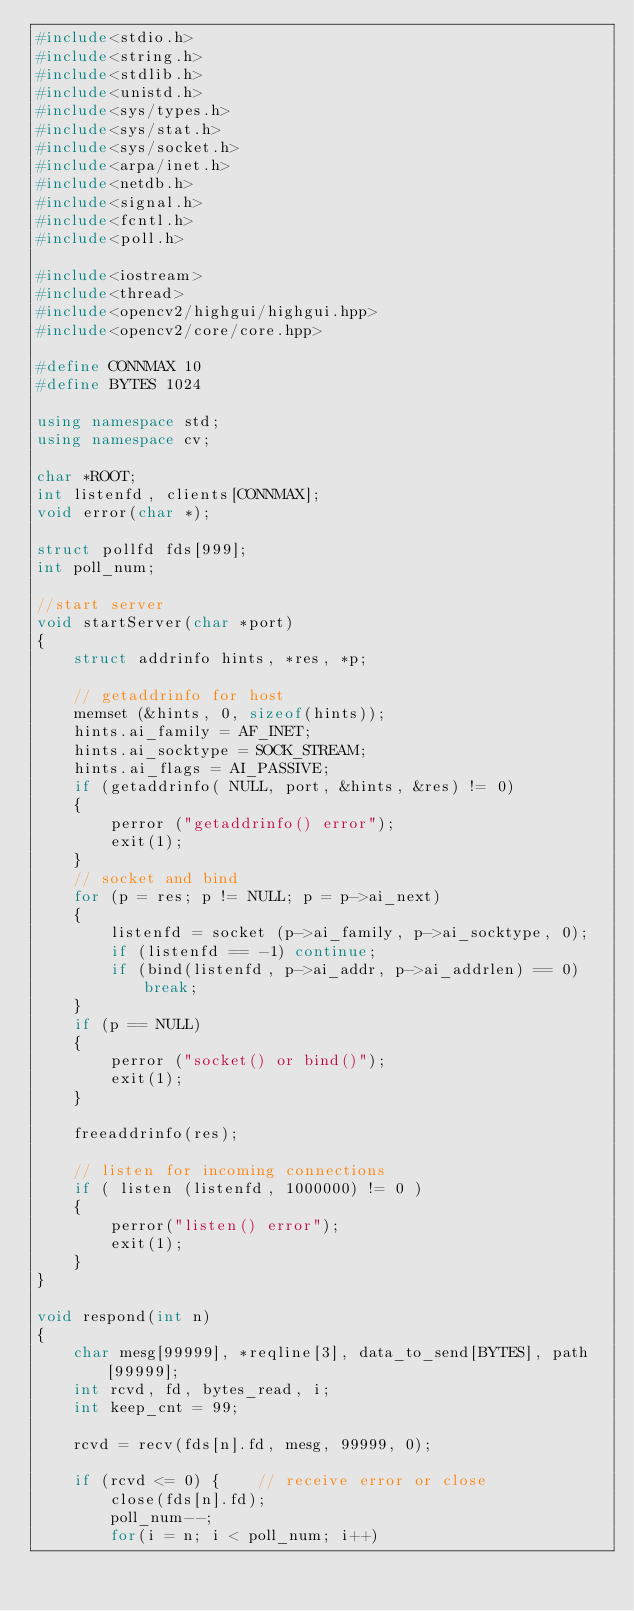<code> <loc_0><loc_0><loc_500><loc_500><_C++_>#include<stdio.h>
#include<string.h>
#include<stdlib.h>
#include<unistd.h>
#include<sys/types.h>
#include<sys/stat.h>
#include<sys/socket.h>
#include<arpa/inet.h>
#include<netdb.h>
#include<signal.h>
#include<fcntl.h>
#include<poll.h>

#include<iostream>
#include<thread>
#include<opencv2/highgui/highgui.hpp>
#include<opencv2/core/core.hpp>

#define CONNMAX 10
#define BYTES 1024

using namespace std;
using namespace cv;

char *ROOT;
int listenfd, clients[CONNMAX];
void error(char *);

struct pollfd fds[999];
int poll_num;

//start server
void startServer(char *port)
{
    struct addrinfo hints, *res, *p;

    // getaddrinfo for host
    memset (&hints, 0, sizeof(hints));
    hints.ai_family = AF_INET;
    hints.ai_socktype = SOCK_STREAM;
    hints.ai_flags = AI_PASSIVE;
    if (getaddrinfo( NULL, port, &hints, &res) != 0)
    {
        perror ("getaddrinfo() error");
        exit(1);
    }
    // socket and bind
    for (p = res; p != NULL; p = p->ai_next)
    {
        listenfd = socket (p->ai_family, p->ai_socktype, 0);
        if (listenfd == -1) continue;
        if (bind(listenfd, p->ai_addr, p->ai_addrlen) == 0) break;
    }
    if (p == NULL)
    {
        perror ("socket() or bind()");
        exit(1);
    }

    freeaddrinfo(res);

    // listen for incoming connections
    if ( listen (listenfd, 1000000) != 0 )
    {
        perror("listen() error");
        exit(1);
    }
}

void respond(int n)
{
    char mesg[99999], *reqline[3], data_to_send[BYTES], path[99999];
    int rcvd, fd, bytes_read, i;
    int keep_cnt = 99;

    rcvd = recv(fds[n].fd, mesg, 99999, 0);

    if (rcvd <= 0) {    // receive error or close
        close(fds[n].fd);
        poll_num--;
        for(i = n; i < poll_num; i++)</code> 